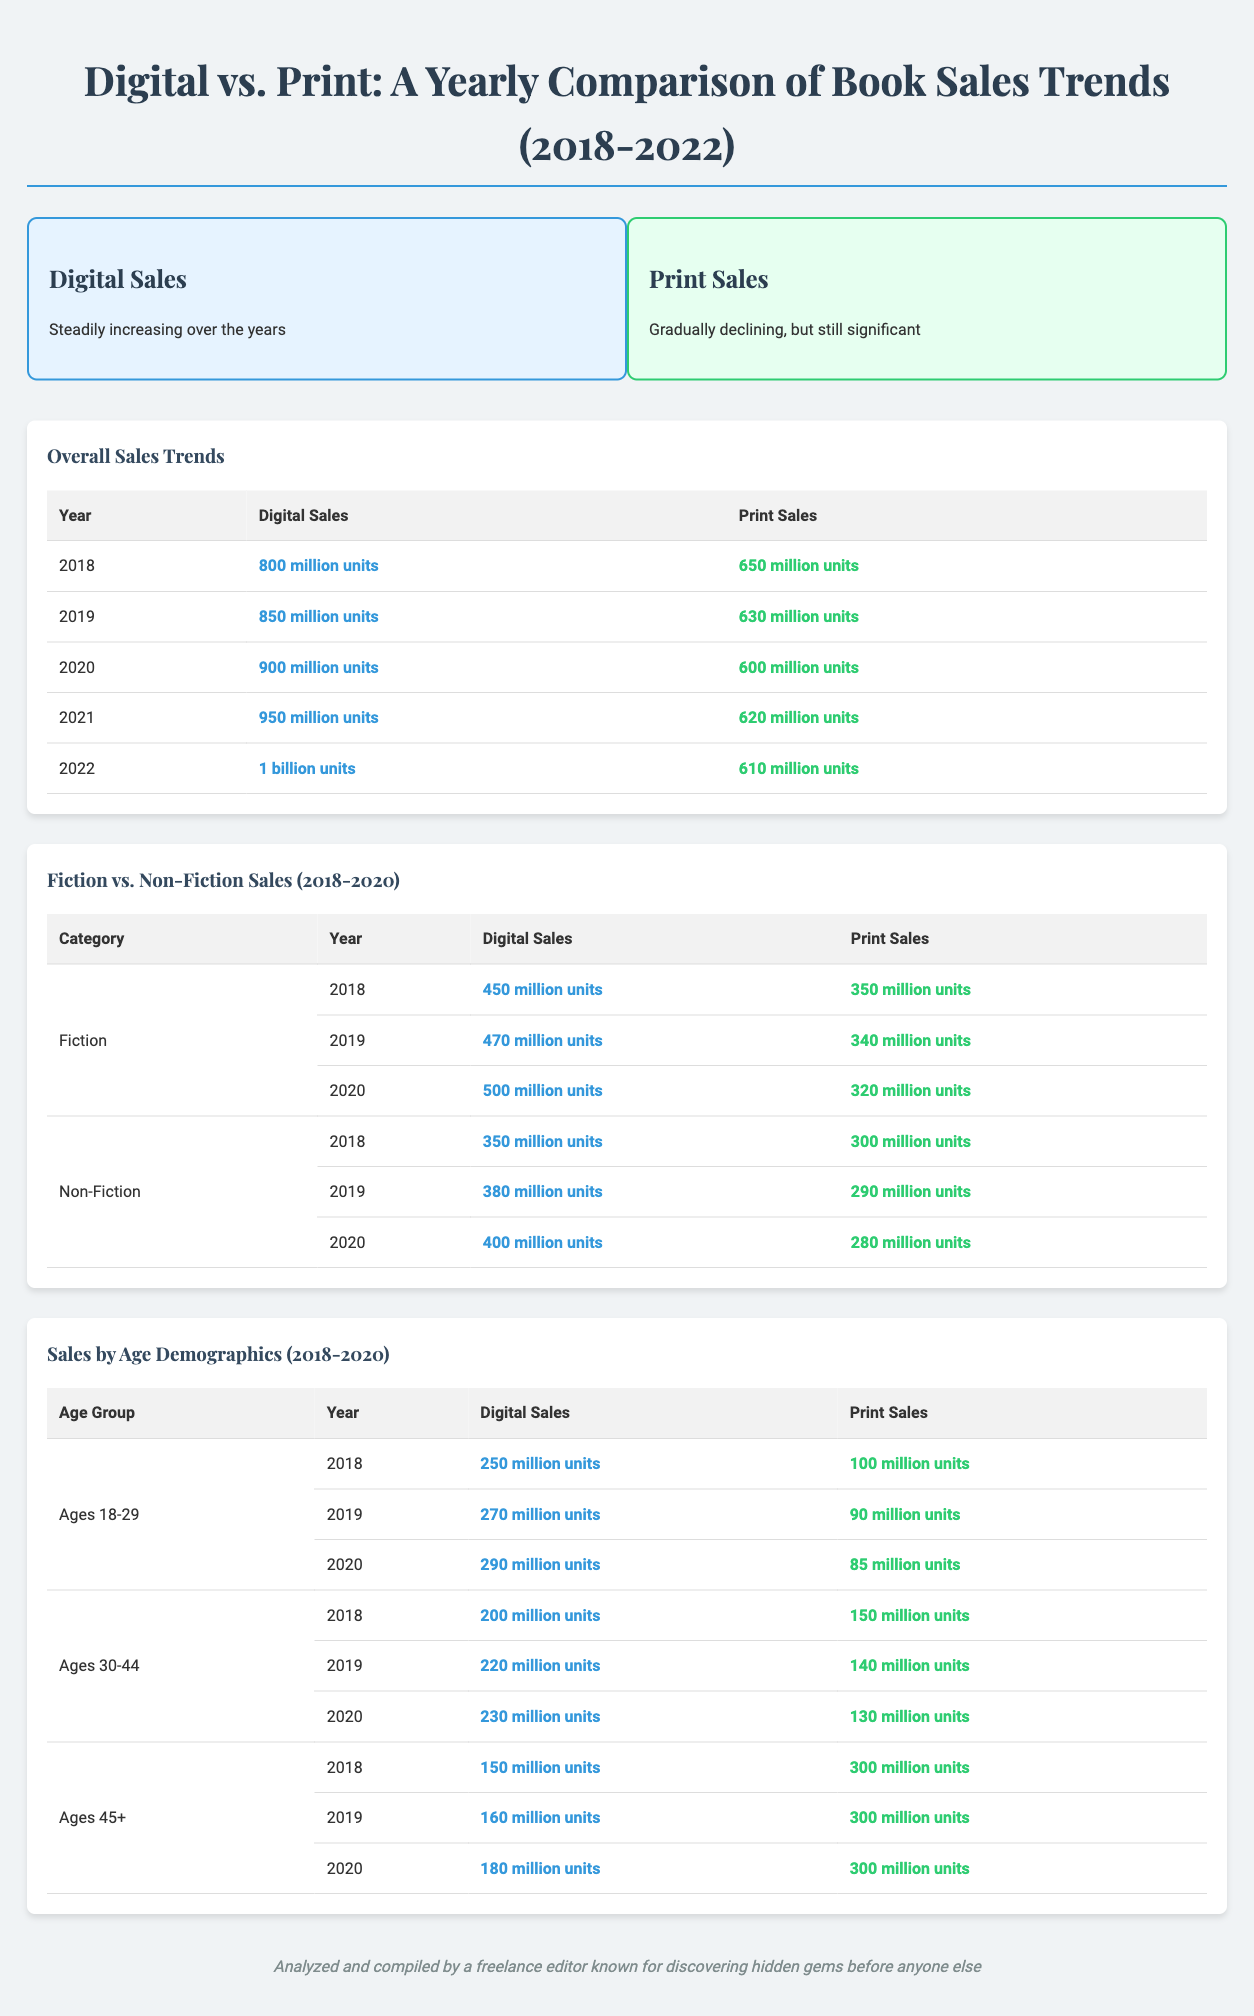What is the highest number of digital sales recorded? The highest number of digital sales recorded in the table is 1 billion units in 2022.
Answer: 1 billion units Which category had more print sales in 2018, Fiction or Non-Fiction? In 2018, Fiction had 350 million units while Non-Fiction had 300 million units in print sales.
Answer: Fiction What was the trend in print sales from 2018 to 2022? The trend in print sales showed a gradual decline from 650 million units in 2018 to 610 million units in 2022.
Answer: Gradual decline How many digital sales were made in 2020 for the age group 45+? The digital sales for the age group 45+ in 2020 were 180 million units.
Answer: 180 million units Which age group had the highest print sales in 2018? The age group 45+ had the highest print sales in 2018 with 300 million units.
Answer: 45+ What is the total digital sales for Non-Fiction from 2018 to 2020? The digital sales for Non-Fiction are 350 million (2018) + 380 million (2019) + 400 million (2020) totaling 1130 million units.
Answer: 1130 million units What color theme is used for digital sales in the infographic? The color theme used for digital sales is light blue.
Answer: Light blue What was the percentage decline in print sales from 2018 to 2022? The decline was from 650 million units to 610 million units, which is a drop of approximately 6.15%.
Answer: 6.15% Which year had the lowest digital sales in the comparison? The lowest digital sales were recorded in 2018 with 800 million units.
Answer: 2018 